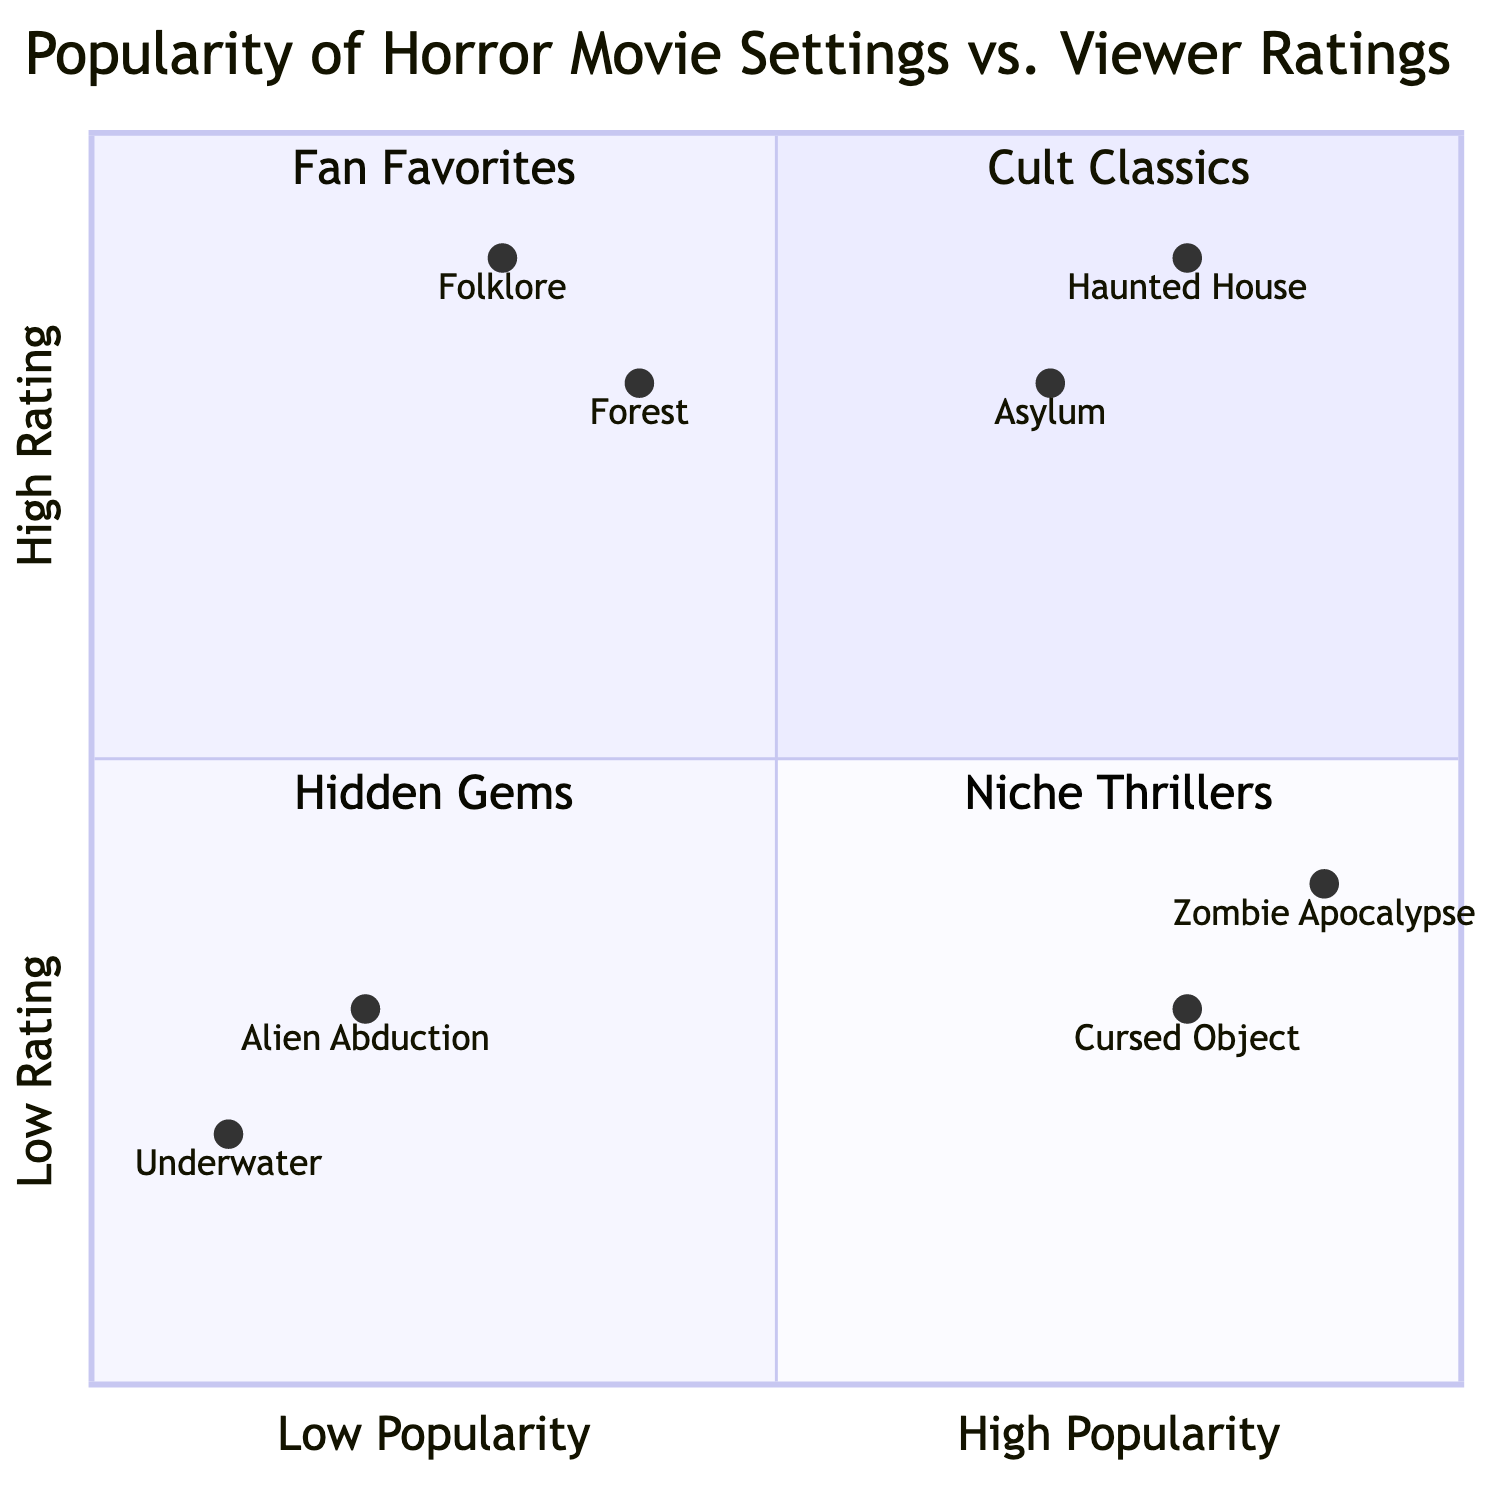What setting has the highest viewer rating? The highest rating in the diagram is 0.9, which belongs to the "Haunted House" setting. This can be verified by checking the y-axis values for various settings.
Answer: Haunted House How many settings are in the "Low Popularity - High Rating" quadrant? The "Low Popularity - High Rating" quadrant contains two settings: "Folklore" and "Forest". By counting the provided data in this quadrant, there are two entries.
Answer: 2 Which setting is associated with "Cursed Object"? The "Cursed Object" setting is located in the "High Popularity - Low Rating" quadrant. By referring to the data given, you can identify the associated movies.
Answer: Cursed Object What is the viewer rating of the "Alien Abduction" setting? The viewer rating for "Alien Abduction" is 0.3 as per the values plotted in the diagram. This value can be found in the low rating area of the quadrants.
Answer: 0.3 Which quadrant contains the "Asylum" setting? The "Asylum" setting is located in the "High Popularity - High Rating" quadrant, which means it has both high viewer engagement and positive reviews. You can determine this by referencing the quadrant classifications in the diagram.
Answer: High Popularity - High Rating How does the "Zombie Apocalypse" setting's popularity compare to its rating? "Zombie Apocalypse" has high popularity with a rating of 0.4, indicating a disparity where it is popular but not well-rated. This can be concluded by examining its coordinates in the diagram.
Answer: High popularity, low rating Which two settings are categorized in the "Niche Thrillers" quadrant? The "Niche Thrillers" quadrant contains the "Alien Abduction" and "Underwater" settings. This can be confirmed by looking at the lower left section of the quadrant chart.
Answer: Alien Abduction, Underwater What is the average viewer rating of the settings in the "Low Popularity - Low Rating" quadrant? The average viewer rating can be calculated as (0.3 + 0.2) / 2, which equals 0.25. This involves finding the ratings of the two settings in this quadrant and averaging them.
Answer: 0.25 Which setting has a higher popularity, "Haunted House" or "Forest"? "Haunted House" has a popularity of 0.8, while "Forest" has a popularity of 0.4. Comparing these values shows that "Haunted House" is more popular.
Answer: Haunted House What movies are associated with the "Folklore" setting? The "Folklore" setting is associated with the movies "The Witch" and "Midsommar", which can be found in the data linked to that specific setting.
Answer: The Witch, Midsommar 